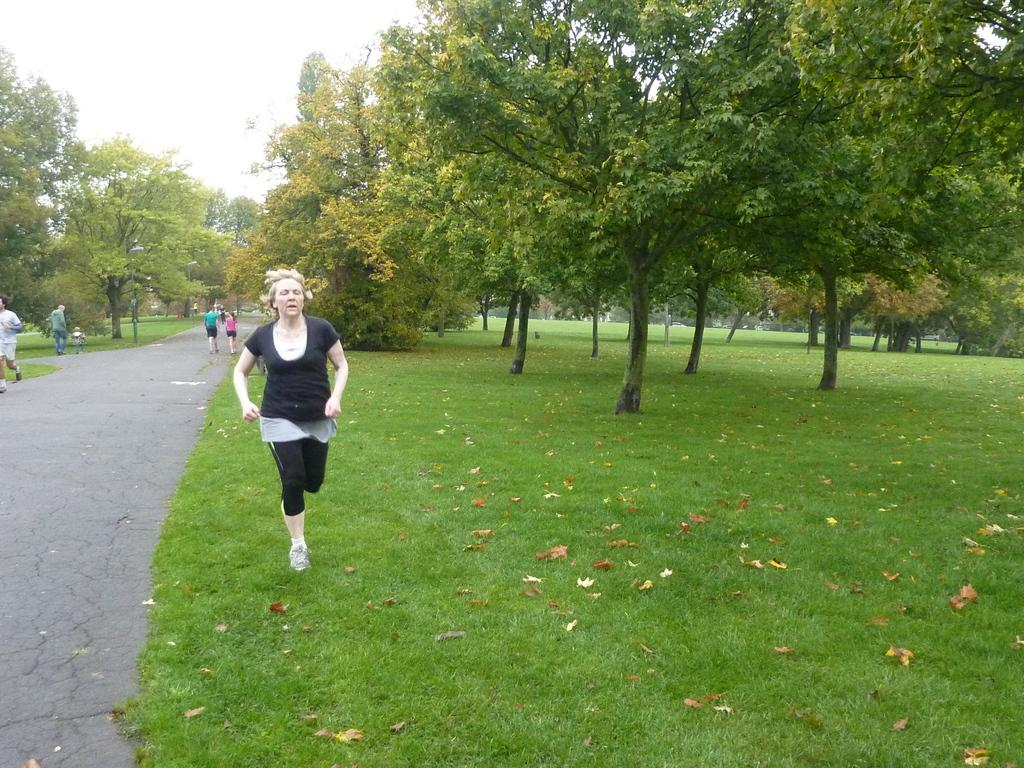What are the people in the image doing? The people in the image are walking on the road. What can be seen on the left side of the image? There are trees and grass on the left side of the image. What can be seen on the right side of the image? There are trees and grass on the right side of the image. What is visible in the background of the image? The sky is visible in the background of the image. What type of attention is the stage receiving in the image? There is no stage present in the image, so it is not possible to determine what type of attention it might be receiving. 